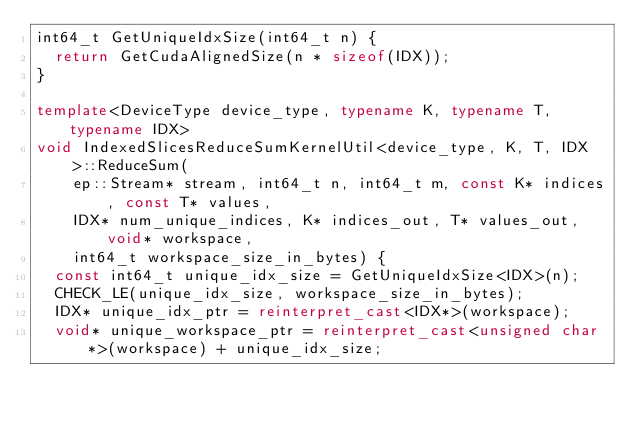<code> <loc_0><loc_0><loc_500><loc_500><_C++_>int64_t GetUniqueIdxSize(int64_t n) {
  return GetCudaAlignedSize(n * sizeof(IDX));
}

template<DeviceType device_type, typename K, typename T, typename IDX>
void IndexedSlicesReduceSumKernelUtil<device_type, K, T, IDX>::ReduceSum(
    ep::Stream* stream, int64_t n, int64_t m, const K* indices, const T* values,
    IDX* num_unique_indices, K* indices_out, T* values_out, void* workspace,
    int64_t workspace_size_in_bytes) {
  const int64_t unique_idx_size = GetUniqueIdxSize<IDX>(n);
  CHECK_LE(unique_idx_size, workspace_size_in_bytes);
  IDX* unique_idx_ptr = reinterpret_cast<IDX*>(workspace);
  void* unique_workspace_ptr = reinterpret_cast<unsigned char*>(workspace) + unique_idx_size;</code> 